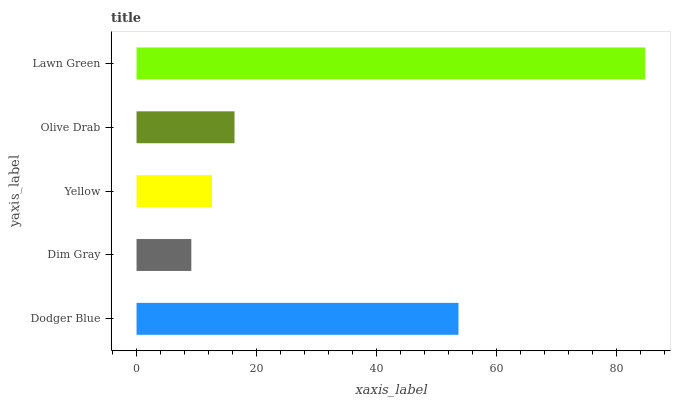Is Dim Gray the minimum?
Answer yes or no. Yes. Is Lawn Green the maximum?
Answer yes or no. Yes. Is Yellow the minimum?
Answer yes or no. No. Is Yellow the maximum?
Answer yes or no. No. Is Yellow greater than Dim Gray?
Answer yes or no. Yes. Is Dim Gray less than Yellow?
Answer yes or no. Yes. Is Dim Gray greater than Yellow?
Answer yes or no. No. Is Yellow less than Dim Gray?
Answer yes or no. No. Is Olive Drab the high median?
Answer yes or no. Yes. Is Olive Drab the low median?
Answer yes or no. Yes. Is Dim Gray the high median?
Answer yes or no. No. Is Dim Gray the low median?
Answer yes or no. No. 